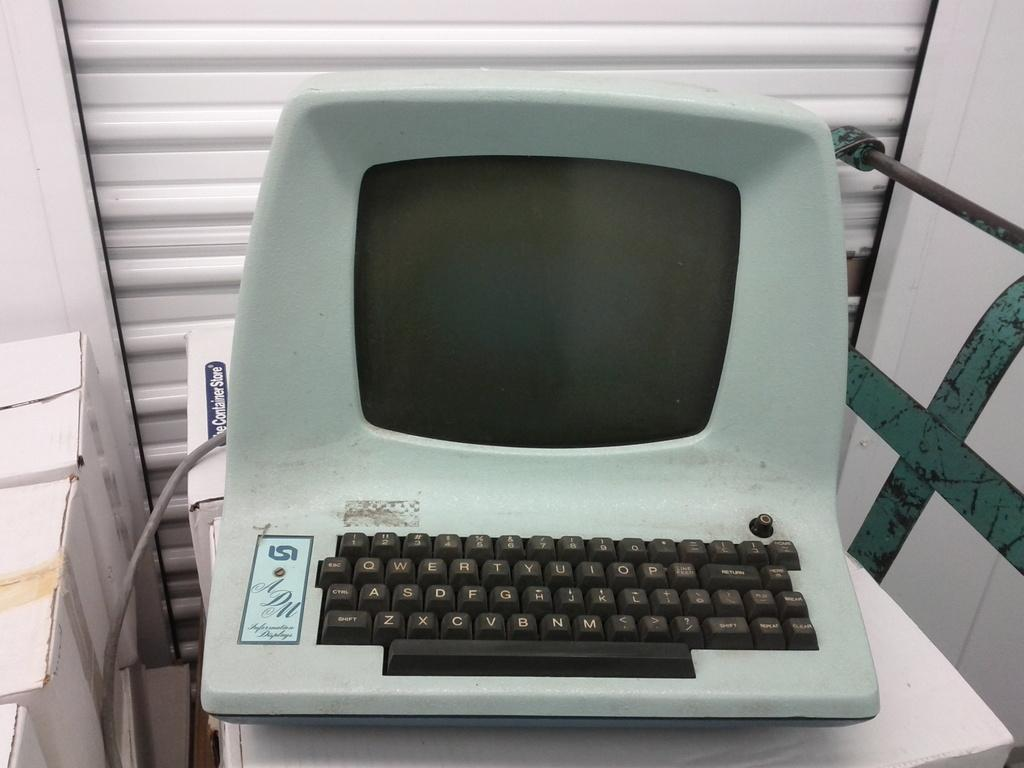<image>
Render a clear and concise summary of the photo. An extremely old computer with the initials ISI on the logo plate is currently not turned on. 